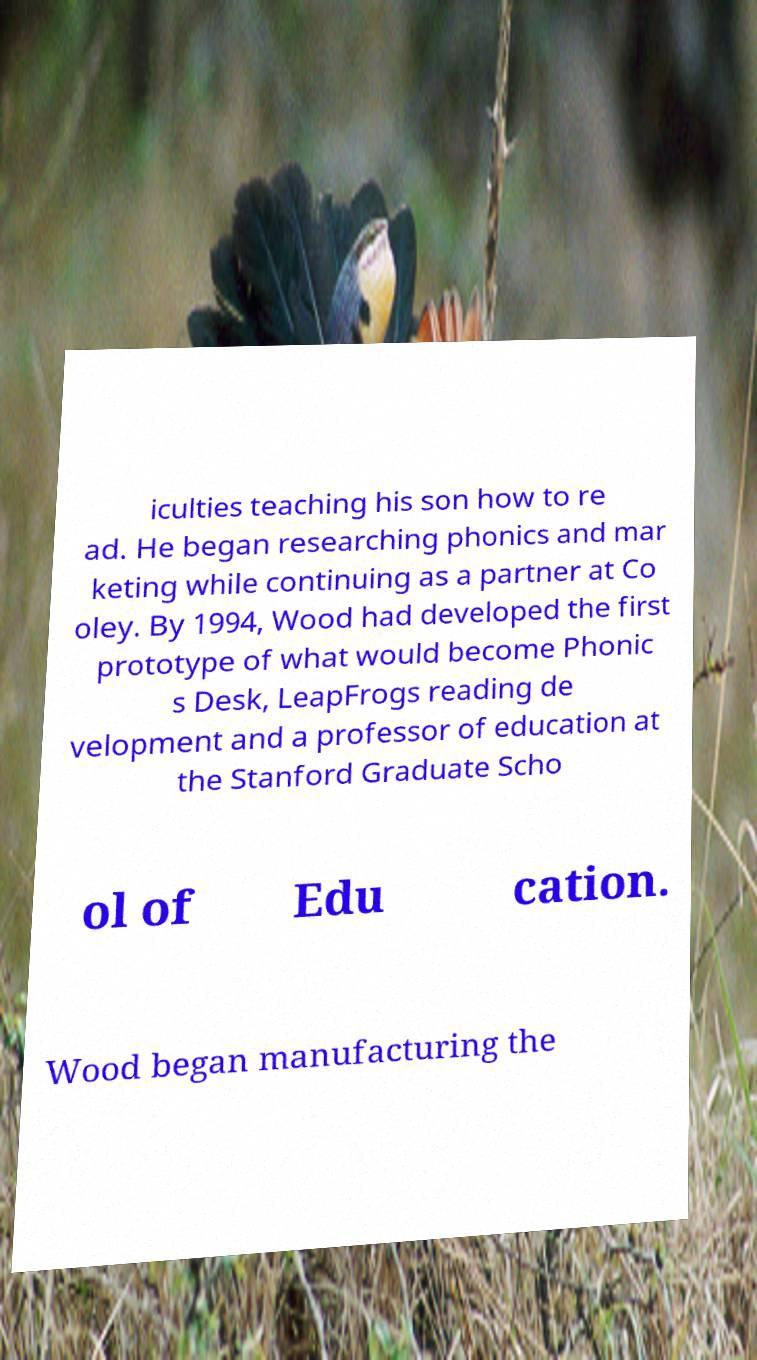Could you assist in decoding the text presented in this image and type it out clearly? iculties teaching his son how to re ad. He began researching phonics and mar keting while continuing as a partner at Co oley. By 1994, Wood had developed the first prototype of what would become Phonic s Desk, LeapFrogs reading de velopment and a professor of education at the Stanford Graduate Scho ol of Edu cation. Wood began manufacturing the 